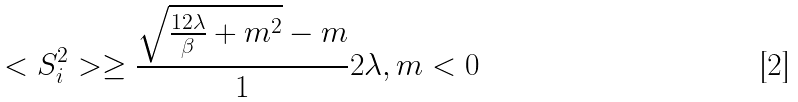<formula> <loc_0><loc_0><loc_500><loc_500>< S _ { i } ^ { 2 } > \geq \frac { \sqrt { \frac { 1 2 \lambda } { \beta } + m ^ { 2 } } - m } 1 2 \lambda , m < 0</formula> 